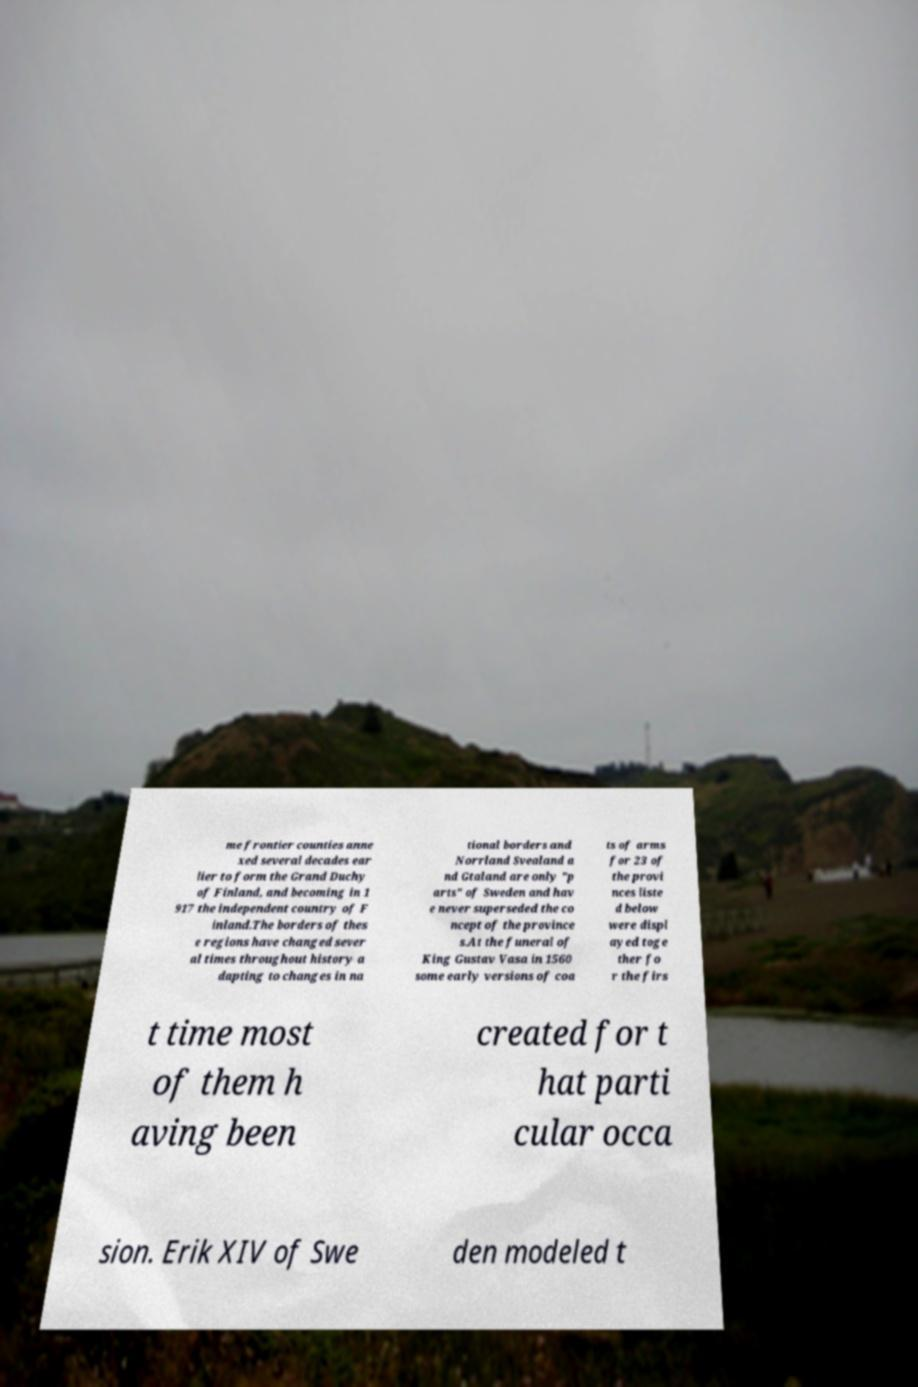I need the written content from this picture converted into text. Can you do that? me frontier counties anne xed several decades ear lier to form the Grand Duchy of Finland, and becoming in 1 917 the independent country of F inland.The borders of thes e regions have changed sever al times throughout history a dapting to changes in na tional borders and Norrland Svealand a nd Gtaland are only "p arts" of Sweden and hav e never superseded the co ncept of the province s.At the funeral of King Gustav Vasa in 1560 some early versions of coa ts of arms for 23 of the provi nces liste d below were displ ayed toge ther fo r the firs t time most of them h aving been created for t hat parti cular occa sion. Erik XIV of Swe den modeled t 